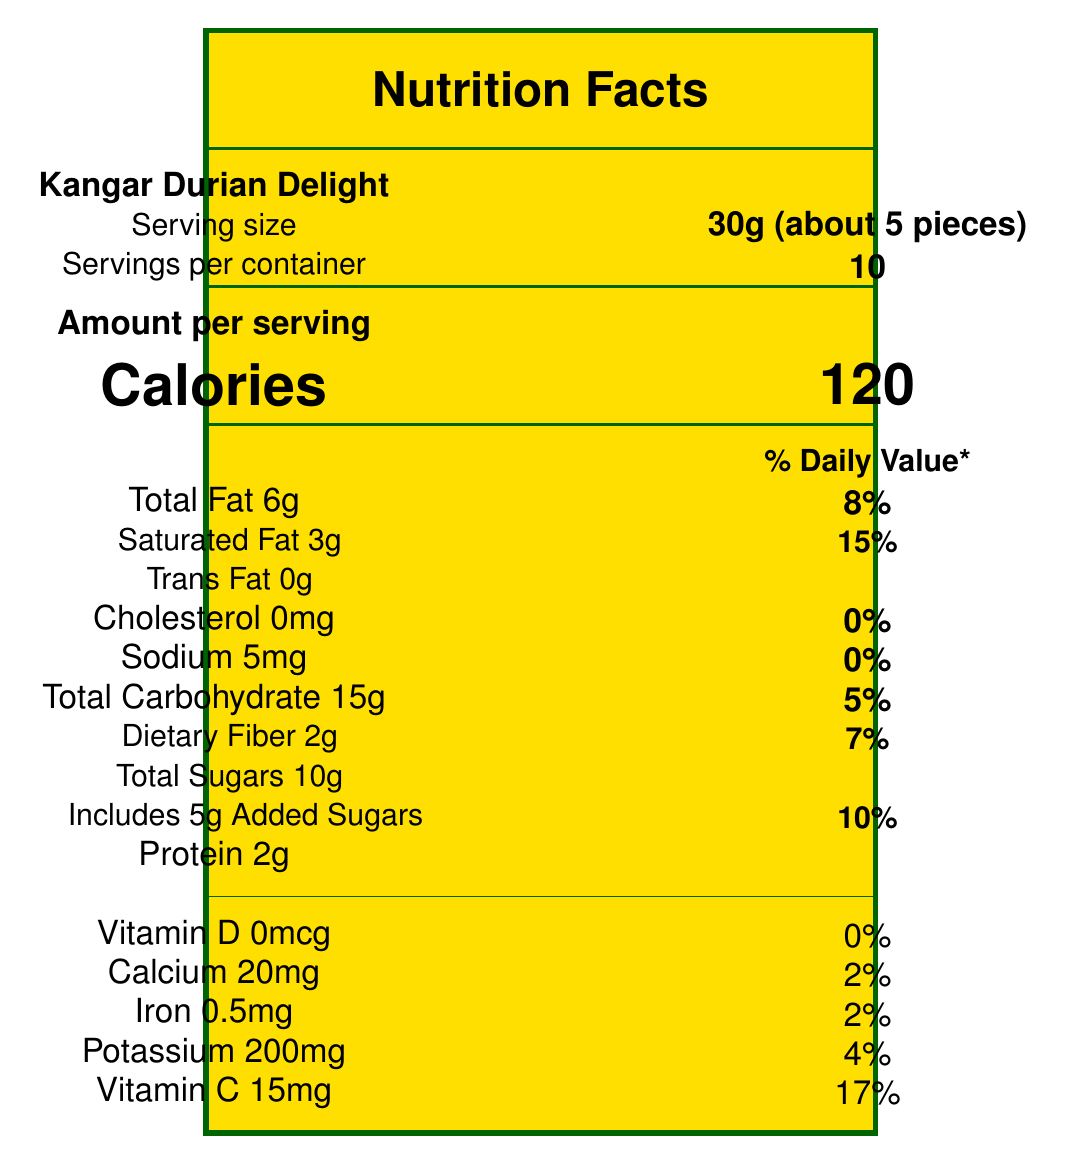what is the serving size? The document states that the serving size is 30g, which is approximately 5 pieces.
Answer: 30g (about 5 pieces) how many calories are there per serving? Under the "Amount per serving" section, the document specifies that there are 120 calories per serving.
Answer: 120 calories how much total fat is in one serving, and what is its daily value percentage? The document mentions that one serving contains 6g of total fat, which is 8% of the daily value.
Answer: 6g, 8% how much dietary fiber is in one serving? The document specifies that one serving contains 2g of dietary fiber.
Answer: 2g what is the vitamin C content per serving, and what percentage of the daily value does it provide? The document indicates that each serving contains 15mg of Vitamin C, which is 17% of the daily value.
Answer: 15mg, 17% how many servings are there per container? The document lists that there are 10 servings per container.
Answer: 10 what is the total carbohydrate amount per serving? According to the document, each serving has 15g of total carbohydrates.
Answer: 15g how much saturated fat is in one serving? A. 1g B. 2g C. 3g D. 4g The document says that one serving contains 3g of saturated fat.
Answer: C. 3g what percentage of the daily value does the sodium in one serving provide? A. 0% B. 3% C. 5% D. 10% The document mentions that the sodium content provides 0% of the daily value.
Answer: A. 0% does this snack contain any trans fat? The document specifies that the trans fat content is 0g, meaning it does not contain any trans fat.
Answer: No is this product certified by JAKIM Halal? The document lists that the product is JAKIM Halal Certified.
Answer: Yes describe the main idea of this document. The document provides detailed nutritional information and other relevant data for understanding the health and consumption aspects of the "Kangar Durian Delight" snack.
Answer: The document is a Nutrition Facts Label for "Kangar Durian Delight," a durian fruit snack produced by Perlis Fruit Delicacies Sdn Bhd in Kangar, Perlis. It details the serving size, calories, and nutrient contents per serving, including fats, carbohydrates, proteins, vitamins, and minerals. It also includes information on ingredients, allergen warnings, and certifications such as JAKIM Halal and HACCP. what is the expiration date of the product? The document does not visually display the expiration date of the product.
Answer: Not enough information who is the manufacturer of the Kangar Durian Delight? The document states that the manufacturer is "Perlis Fruit Delicacies Sdn Bhd," located in Jalan Bukit Lagi, 01000 Kangar, Perlis.
Answer: Perlis Fruit Delicacies Sdn Bhd how much protein does one serving have? The document mentions that each serving contains 2g of protein.
Answer: 2g in what type of facility is this product produced? The document includes an allergen warning stating that the product is produced in a facility that also processes nuts and dairy products.
Answer: In a facility that also processes nuts and dairy products 